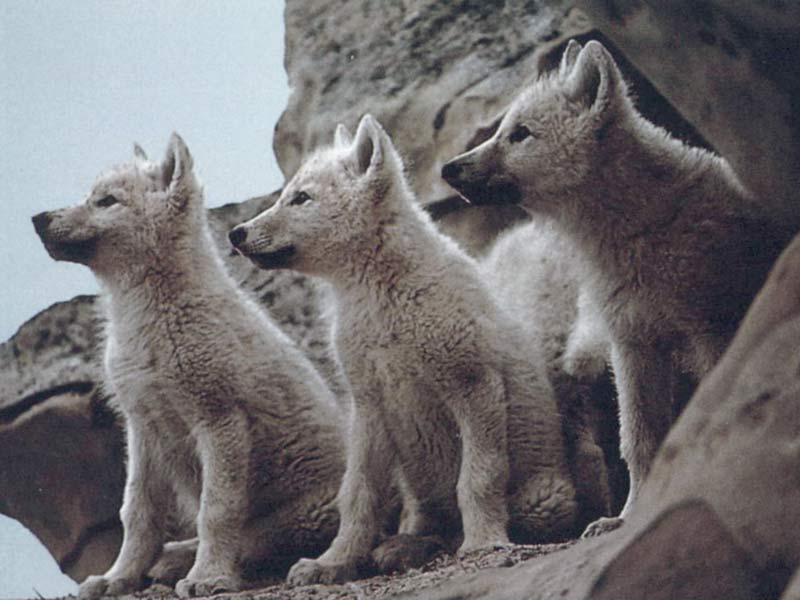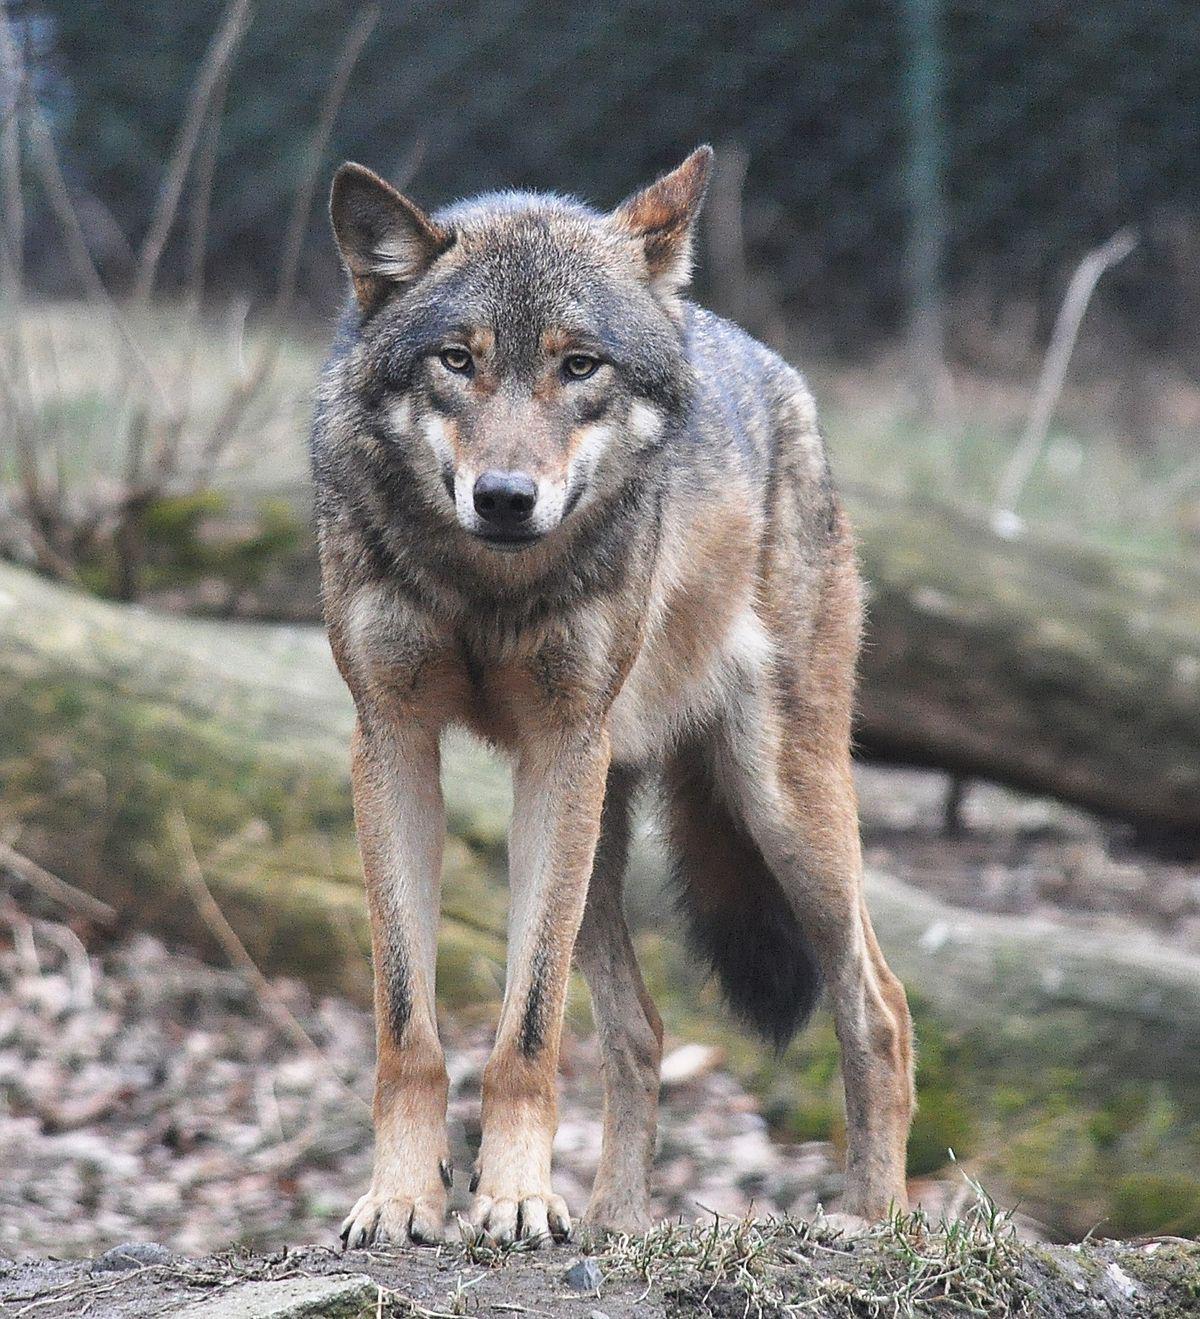The first image is the image on the left, the second image is the image on the right. For the images displayed, is the sentence "An image includes an open-mouthed snarling wolf." factually correct? Answer yes or no. No. The first image is the image on the left, the second image is the image on the right. For the images displayed, is the sentence "The dogs in the image on the left are in a snowy area." factually correct? Answer yes or no. No. 